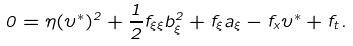Convert formula to latex. <formula><loc_0><loc_0><loc_500><loc_500>0 = \eta ( \upsilon ^ { * } ) ^ { 2 } + \frac { 1 } { 2 } f _ { \xi \xi } b ^ { 2 } _ { \xi } + f _ { \xi } a _ { \xi } - f _ { x } \upsilon ^ { * } + f _ { t } .</formula> 